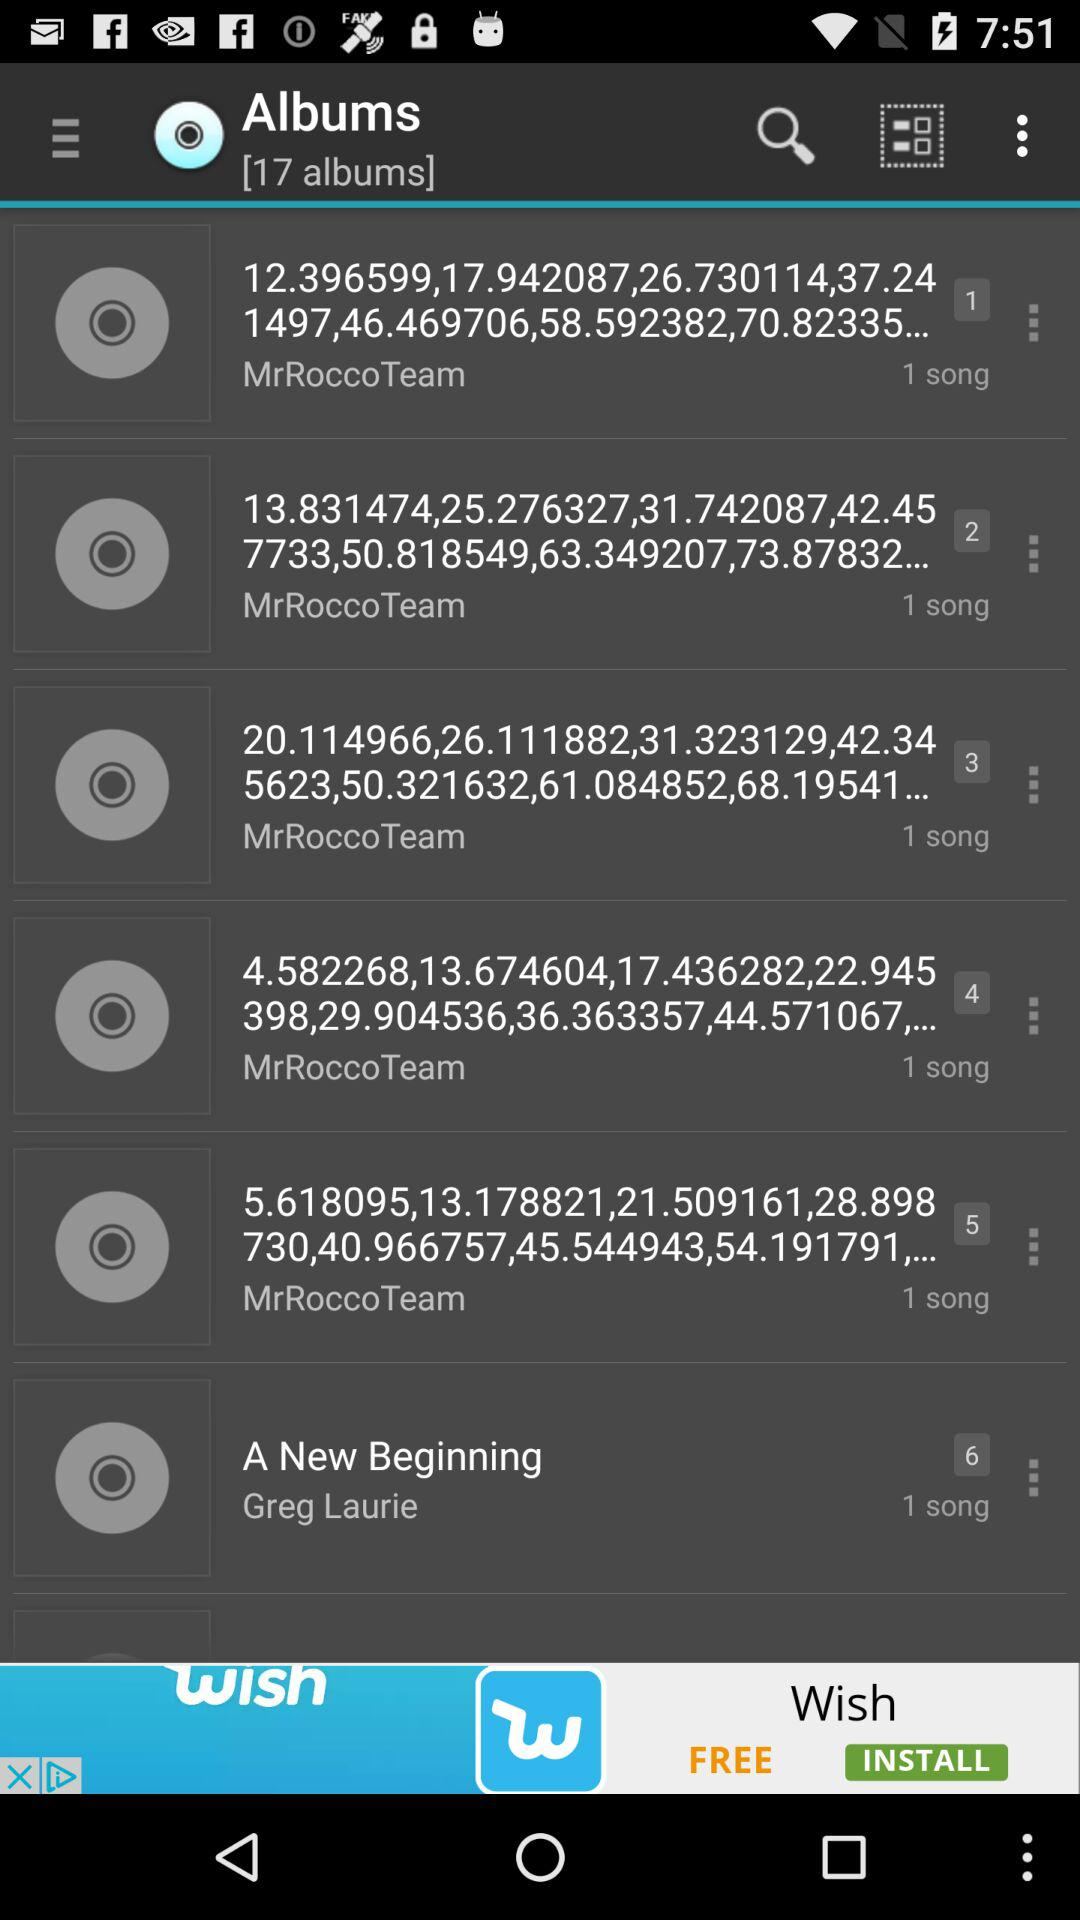How many albums in total are there? There are 17 albums in total. 